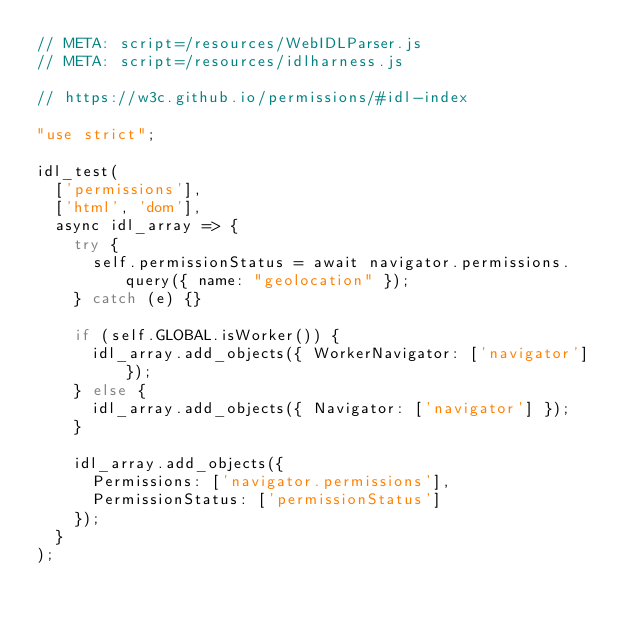<code> <loc_0><loc_0><loc_500><loc_500><_JavaScript_>// META: script=/resources/WebIDLParser.js
// META: script=/resources/idlharness.js

// https://w3c.github.io/permissions/#idl-index

"use strict";

idl_test(
  ['permissions'],
  ['html', 'dom'],
  async idl_array => {
    try {
      self.permissionStatus = await navigator.permissions.query({ name: "geolocation" });
    } catch (e) {}

    if (self.GLOBAL.isWorker()) {
      idl_array.add_objects({ WorkerNavigator: ['navigator'] });
    } else {
      idl_array.add_objects({ Navigator: ['navigator'] });
    }

    idl_array.add_objects({
      Permissions: ['navigator.permissions'],
      PermissionStatus: ['permissionStatus']
    });
  }
);
</code> 